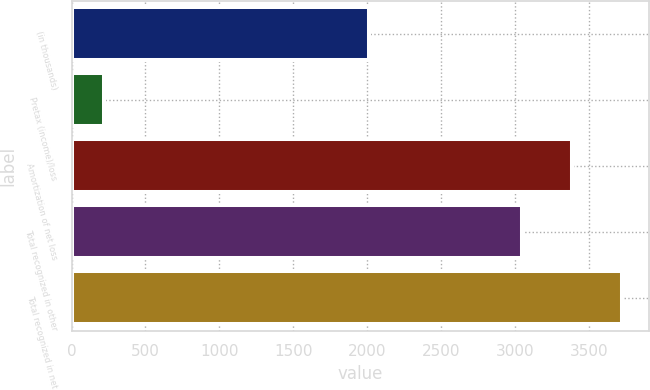Convert chart to OTSL. <chart><loc_0><loc_0><loc_500><loc_500><bar_chart><fcel>(in thousands)<fcel>Pretax (income)/loss<fcel>Amortization of net loss<fcel>Total recognized in other<fcel>Total recognized in net<nl><fcel>2016<fcel>218<fcel>3383.1<fcel>3045<fcel>3721.2<nl></chart> 